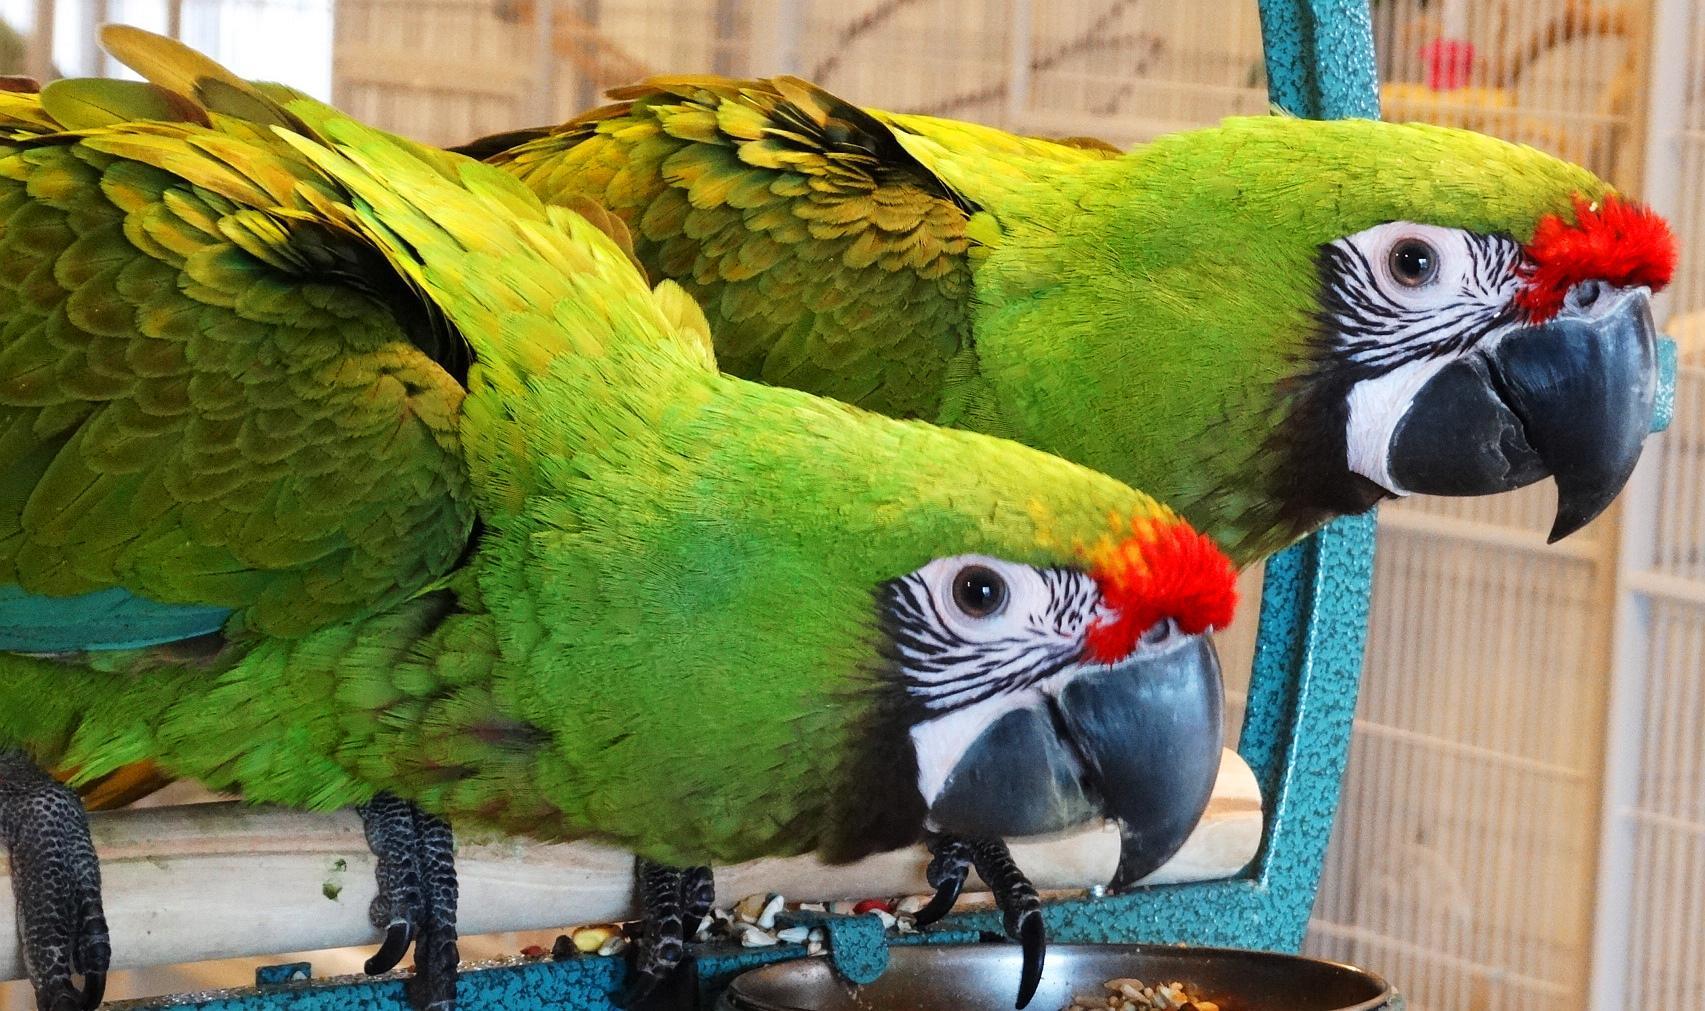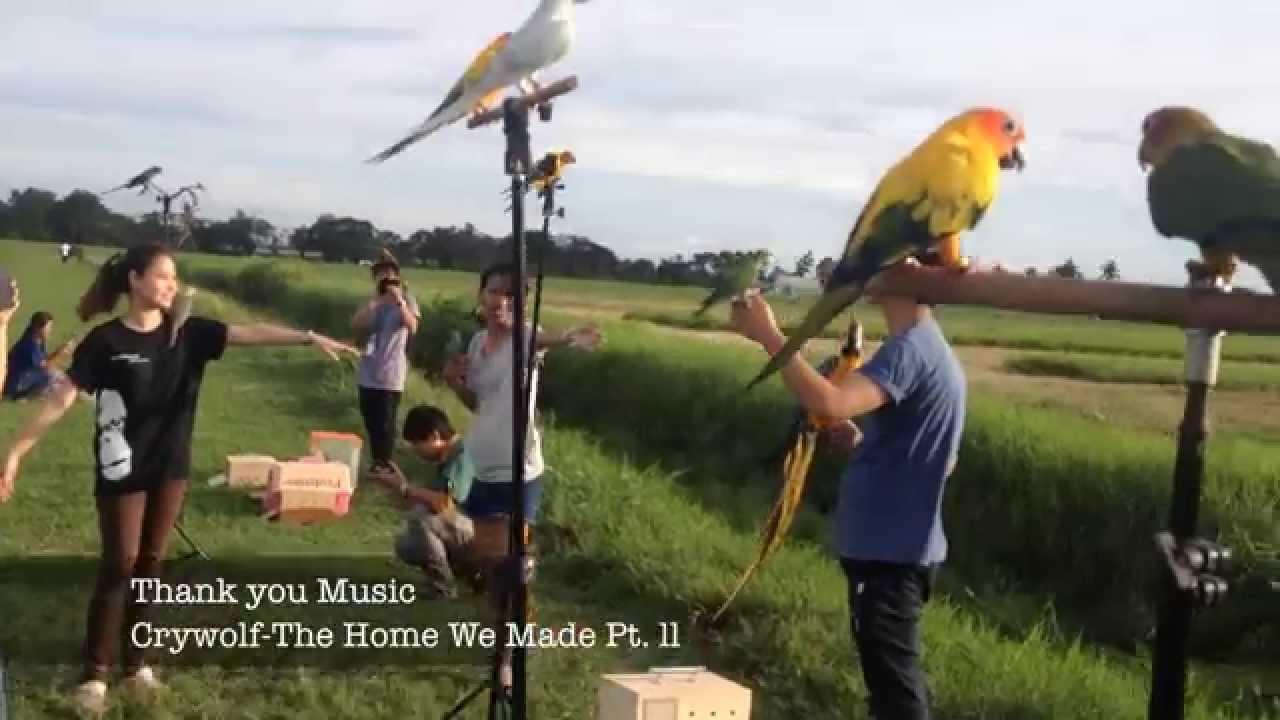The first image is the image on the left, the second image is the image on the right. Considering the images on both sides, is "An image shows a bird perched on a person's extended hand." valid? Answer yes or no. Yes. 